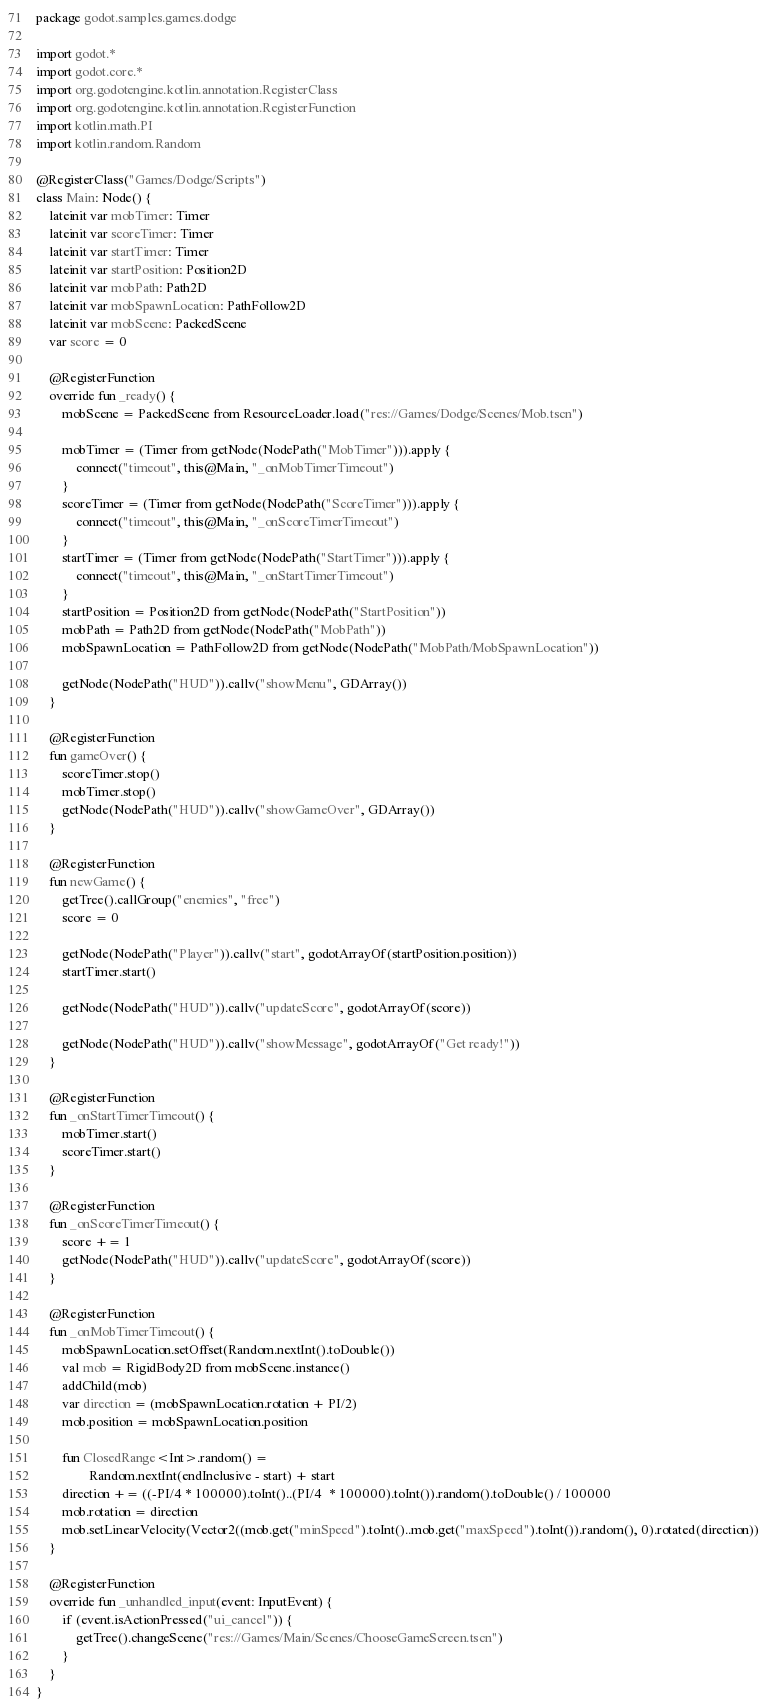<code> <loc_0><loc_0><loc_500><loc_500><_Kotlin_>package godot.samples.games.dodge

import godot.*
import godot.core.*
import org.godotengine.kotlin.annotation.RegisterClass
import org.godotengine.kotlin.annotation.RegisterFunction
import kotlin.math.PI
import kotlin.random.Random

@RegisterClass("Games/Dodge/Scripts")
class Main: Node() {
    lateinit var mobTimer: Timer
    lateinit var scoreTimer: Timer
    lateinit var startTimer: Timer
    lateinit var startPosition: Position2D
    lateinit var mobPath: Path2D
    lateinit var mobSpawnLocation: PathFollow2D
    lateinit var mobScene: PackedScene
    var score = 0

    @RegisterFunction
    override fun _ready() {
        mobScene = PackedScene from ResourceLoader.load("res://Games/Dodge/Scenes/Mob.tscn")

        mobTimer = (Timer from getNode(NodePath("MobTimer"))).apply {
            connect("timeout", this@Main, "_onMobTimerTimeout")
        }
        scoreTimer = (Timer from getNode(NodePath("ScoreTimer"))).apply {
            connect("timeout", this@Main, "_onScoreTimerTimeout")
        }
        startTimer = (Timer from getNode(NodePath("StartTimer"))).apply {
            connect("timeout", this@Main, "_onStartTimerTimeout")
        }
        startPosition = Position2D from getNode(NodePath("StartPosition"))
        mobPath = Path2D from getNode(NodePath("MobPath"))
        mobSpawnLocation = PathFollow2D from getNode(NodePath("MobPath/MobSpawnLocation"))

        getNode(NodePath("HUD")).callv("showMenu", GDArray())
    }

    @RegisterFunction
    fun gameOver() {
        scoreTimer.stop()
        mobTimer.stop()
        getNode(NodePath("HUD")).callv("showGameOver", GDArray())
    }

    @RegisterFunction
    fun newGame() {
        getTree().callGroup("enemies", "free")
        score = 0

        getNode(NodePath("Player")).callv("start", godotArrayOf(startPosition.position))
        startTimer.start()

        getNode(NodePath("HUD")).callv("updateScore", godotArrayOf(score))

        getNode(NodePath("HUD")).callv("showMessage", godotArrayOf("Get ready!"))
    }

    @RegisterFunction
    fun _onStartTimerTimeout() {
        mobTimer.start()
        scoreTimer.start()
    }

    @RegisterFunction
    fun _onScoreTimerTimeout() {
        score += 1
        getNode(NodePath("HUD")).callv("updateScore", godotArrayOf(score))
    }

    @RegisterFunction
    fun _onMobTimerTimeout() {
        mobSpawnLocation.setOffset(Random.nextInt().toDouble())
        val mob = RigidBody2D from mobScene.instance()
        addChild(mob)
        var direction = (mobSpawnLocation.rotation + PI/2)
        mob.position = mobSpawnLocation.position

        fun ClosedRange<Int>.random() =
                Random.nextInt(endInclusive - start) + start
        direction += ((-PI/4 * 100000).toInt()..(PI/4  * 100000).toInt()).random().toDouble() / 100000
        mob.rotation = direction
        mob.setLinearVelocity(Vector2((mob.get("minSpeed").toInt()..mob.get("maxSpeed").toInt()).random(), 0).rotated(direction))
    }

    @RegisterFunction
    override fun _unhandled_input(event: InputEvent) {
        if (event.isActionPressed("ui_cancel")) {
            getTree().changeScene("res://Games/Main/Scenes/ChooseGameScreen.tscn")
        }
    }
}</code> 